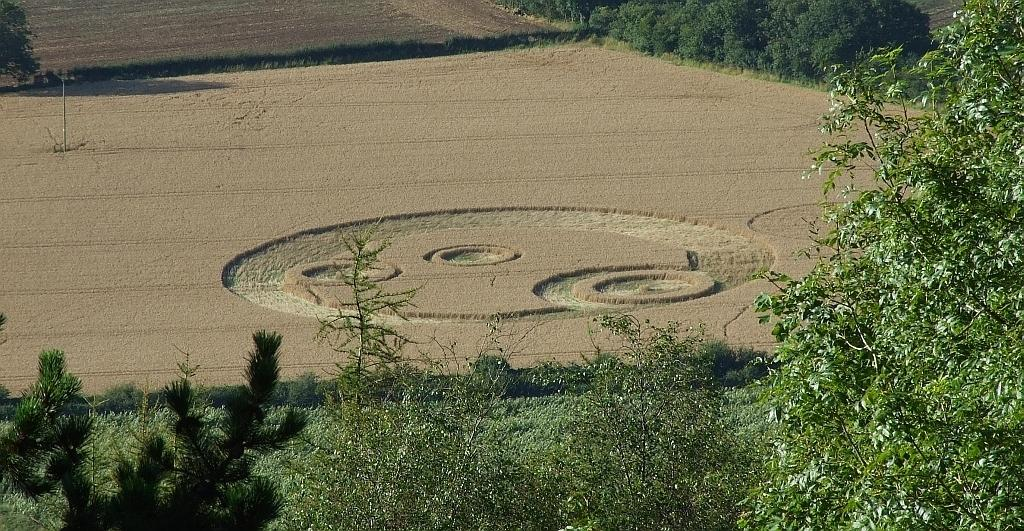Where was the picture taken? The picture was clicked outside. What can be seen in the foreground of the image? There is green grass, plants, and trees in the foreground of the image. What is present in the center of the image? There is mud and other objects in the center of the image. How far away is the pipe from the leg in the image? There is no pipe or leg present in the image. 